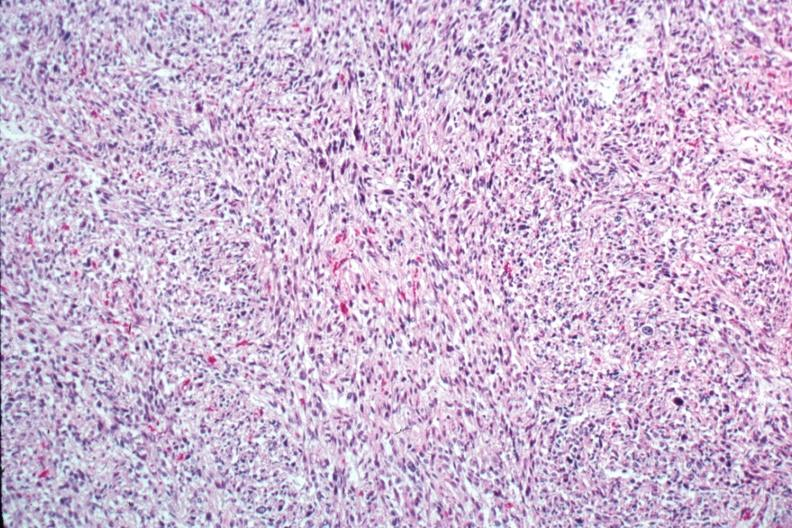s leiomyosarcoma present?
Answer the question using a single word or phrase. Yes 